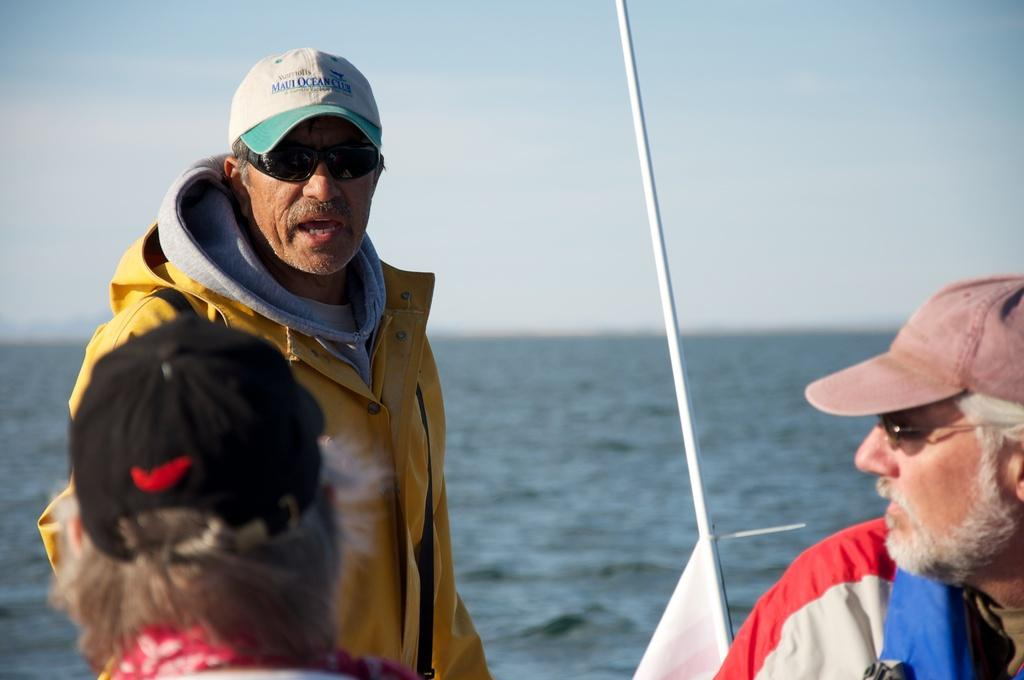What is the main subject of the image? There is a man in the image. Can you describe the man's clothing? The man is wearing a yellow coat. Are there any other people in the image? Yes, there is another man on the right side of the image. How is the second man dressed? The second man is wearing a cap and spectacles. What can be seen in the middle of the image? There is water in the middle of the image. What type of haircut does the man in the yellow coat have in the image? There is no information about the man's haircut in the image. How does the man stretch his arms in the image? There is no indication of the man stretching his arms in the image. 